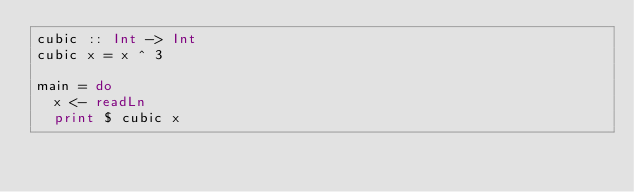Convert code to text. <code><loc_0><loc_0><loc_500><loc_500><_Haskell_>cubic :: Int -> Int
cubic x = x ^ 3

main = do
  x <- readLn
  print $ cubic x</code> 